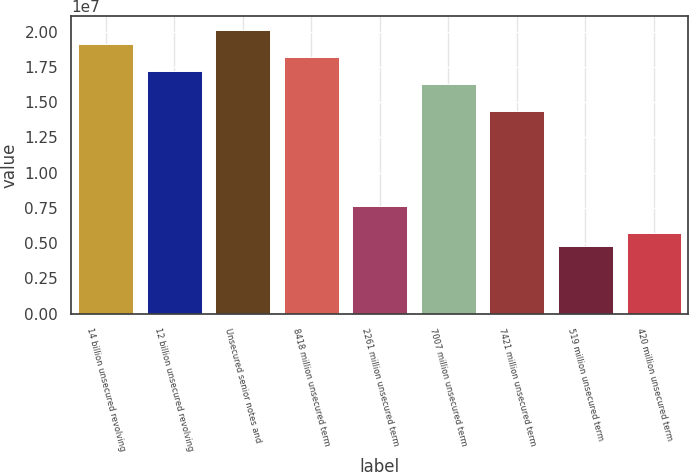Convert chart to OTSL. <chart><loc_0><loc_0><loc_500><loc_500><bar_chart><fcel>14 billion unsecured revolving<fcel>12 billion unsecured revolving<fcel>Unsecured senior notes and<fcel>8418 million unsecured term<fcel>2261 million unsecured term<fcel>7007 million unsecured term<fcel>7421 million unsecured term<fcel>519 million unsecured term<fcel>420 million unsecured term<nl><fcel>1.91427e+07<fcel>1.72291e+07<fcel>2.00995e+07<fcel>1.81859e+07<fcel>7.66104e+06<fcel>1.62723e+07<fcel>1.43587e+07<fcel>4.79062e+06<fcel>5.74743e+06<nl></chart> 